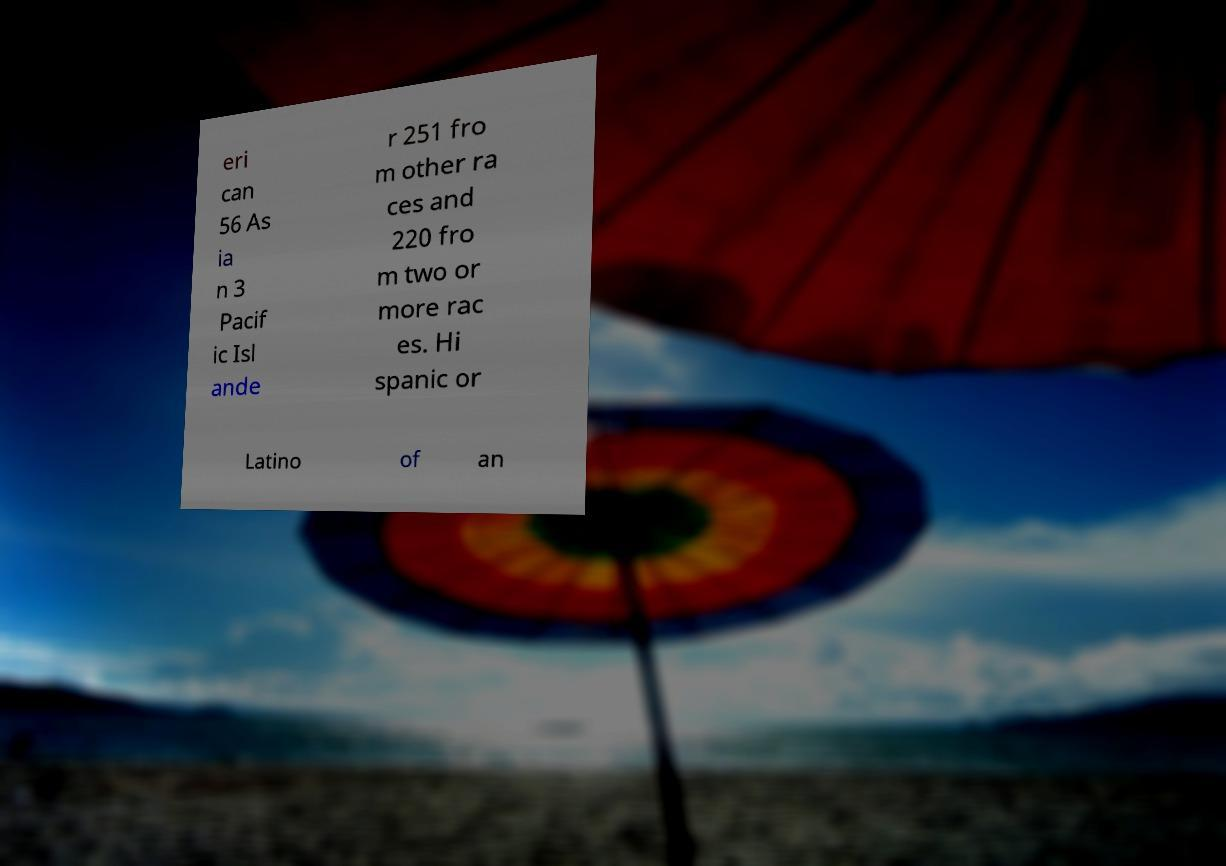What messages or text are displayed in this image? I need them in a readable, typed format. eri can 56 As ia n 3 Pacif ic Isl ande r 251 fro m other ra ces and 220 fro m two or more rac es. Hi spanic or Latino of an 